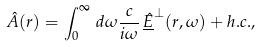Convert formula to latex. <formula><loc_0><loc_0><loc_500><loc_500>\hat { A } ( r ) = \int _ { 0 } ^ { \infty } \, d \omega \frac { c } { i \omega } \, \underline { \hat { E } } ^ { \perp } ( r , \omega ) + h . c . ,</formula> 